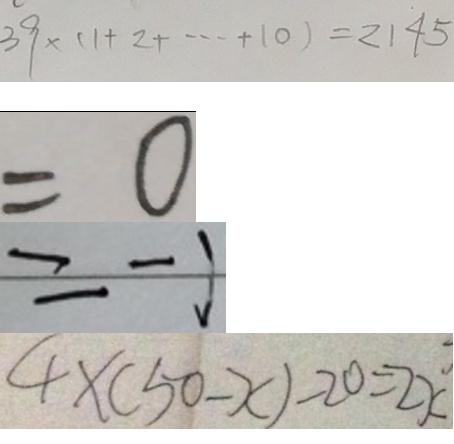Convert formula to latex. <formula><loc_0><loc_0><loc_500><loc_500>3 9 \times ( 1 + 2 + \cdots + 1 0 ) = 2 1 4 5 
 = 0 
 = - 1 
 4 \times ( 5 0 - x ) - 2 0 = 2 x</formula> 